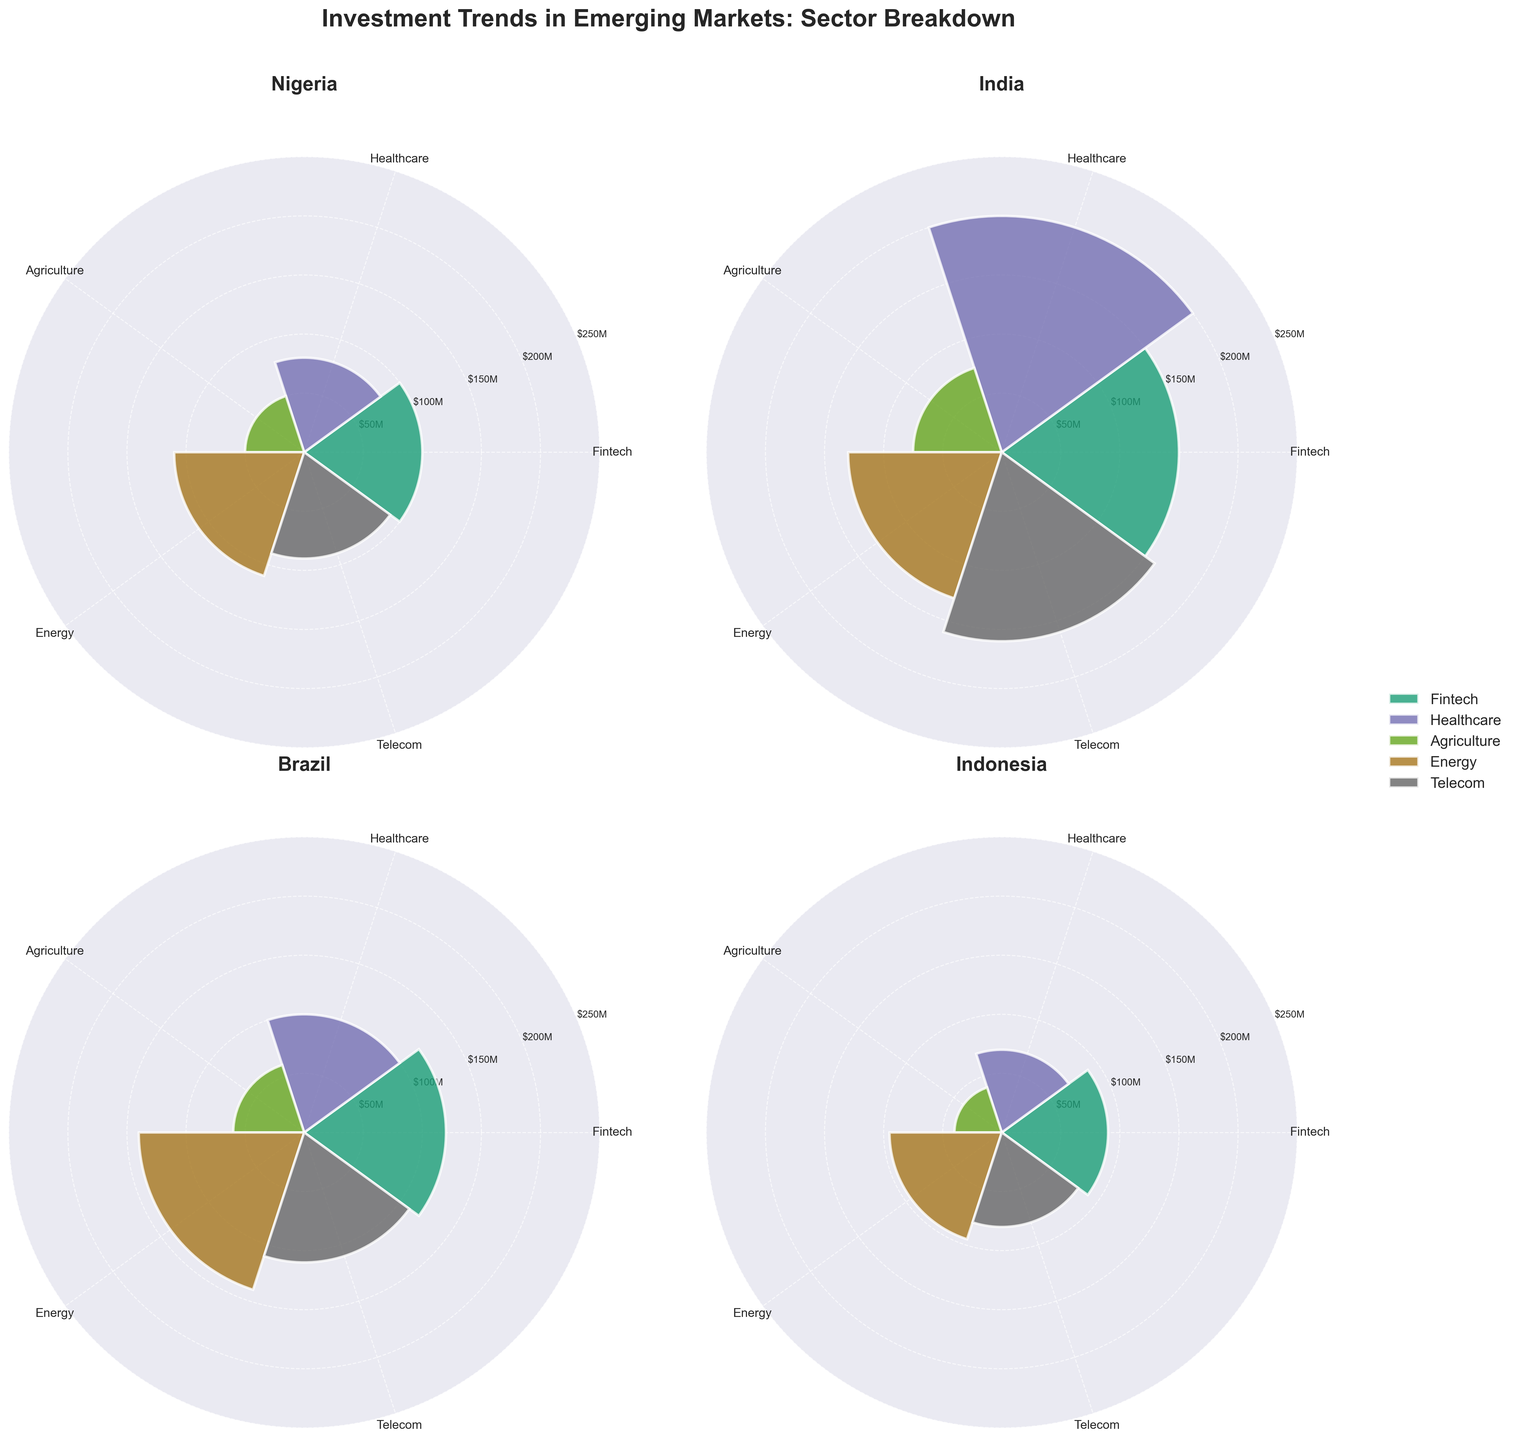Which country received the highest investment in the Fintech sector? By observing the respective segments in each country's subplot, India’s Fintech segment is the tallest, indicating the highest investment.
Answer: India What is the title of the entire figure? The title is clearly stated at the top of the figure, reading "Investment Trends in Emerging Markets: Sector Breakdown."
Answer: Investment Trends in Emerging Markets: Sector Breakdown What is the average investment in the Agriculture sector across all countries? Add the investment amounts for the Agriculture sector in each country (Nigeria: $50M, India: $75M, Brazil: $60M, Indonesia: $40M) and divide by the number of countries. The calculation is (50 + 75 + 60 + 40) / 4 = $56.25M.
Answer: $56.25M Which country has the smallest investment in Healthcare, and what is that amount? By comparing the Healthcare segments in each subplot, Indonesia's segment is the smallest in height. The amount for Indonesia is $70M.
Answer: Indonesia, $70M How does the investment in Nigeria’s Energy sector compare to India’s Telecom sector? By visually comparing the heights of the bars, Nigeria's Energy ($110M) is less than India's Telecom ($160M).
Answer: Nigeria’s Energy is less than India’s Telecom Which sector has the most consistent investment amounts across the countries? Consistency is determined by the similarity in bar heights across all subplots. Agriculture shows the least variation with values of $50M, $75M, $60M, and $40M.
Answer: Agriculture Arrange the countries in descending order according to their investment in the Energy sector. By comparing the heights of the Energy segment in each subplot, Brazil ($140M), India ($130M), Nigeria ($110M), Indonesia ($95M).
Answer: Brazil, India, Nigeria, Indonesia What is the combined investment in the Telecom sector for Nigeria and Brazil? Sum the investment amounts in the Telecom sector for Nigeria ($90M) and Brazil ($110M). The calculation is (90 + 110) = $200M.
Answer: $200M Which country saw the highest total investment across all sectors? Sum the investment amounts across all sectors for each country and compare. India has the highest total with 150 + 200 + 75 + 130 + 160 = $715M.
Answer: India 